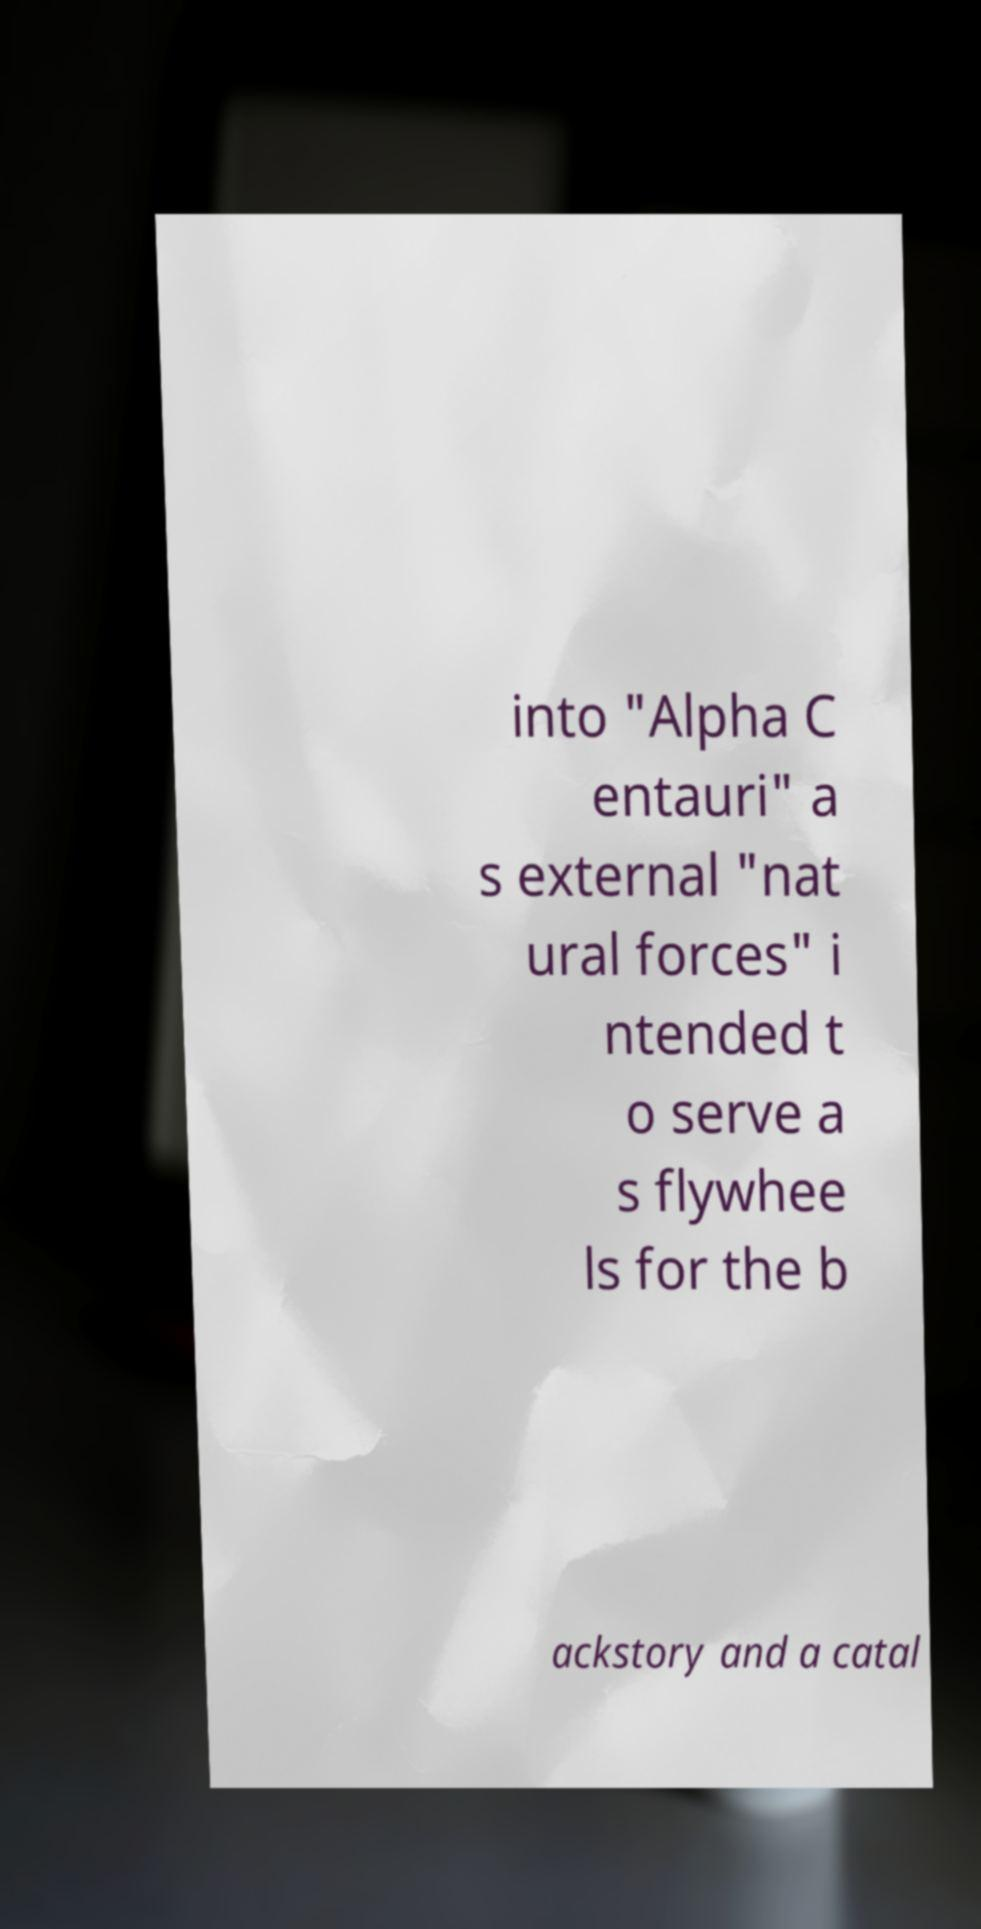For documentation purposes, I need the text within this image transcribed. Could you provide that? into "Alpha C entauri" a s external "nat ural forces" i ntended t o serve a s flywhee ls for the b ackstory and a catal 